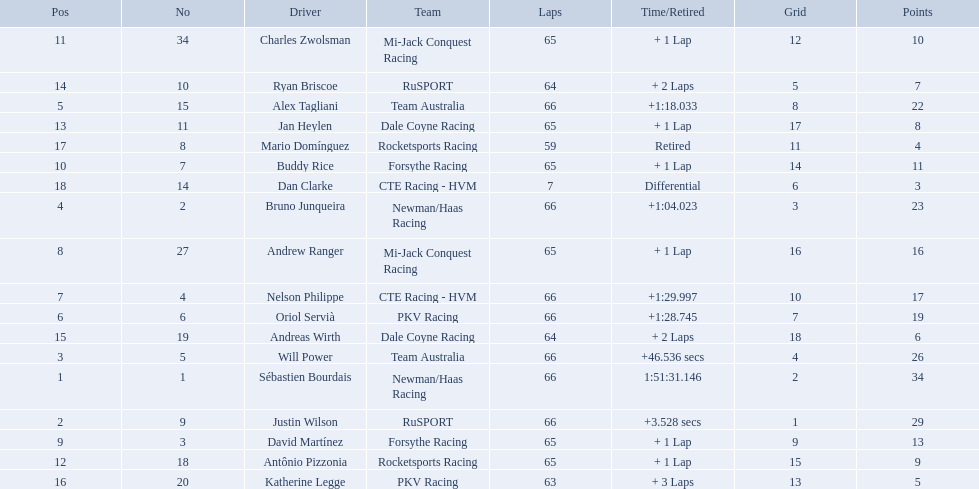Who are the drivers? Sébastien Bourdais, Justin Wilson, Will Power, Bruno Junqueira, Alex Tagliani, Oriol Servià, Nelson Philippe, Andrew Ranger, David Martínez, Buddy Rice, Charles Zwolsman, Antônio Pizzonia, Jan Heylen, Ryan Briscoe, Andreas Wirth, Katherine Legge, Mario Domínguez, Dan Clarke. What are their numbers? 1, 9, 5, 2, 15, 6, 4, 27, 3, 7, 34, 18, 11, 10, 19, 20, 8, 14. What are their positions? 1, 2, 3, 4, 5, 6, 7, 8, 9, 10, 11, 12, 13, 14, 15, 16, 17, 18. Which driver has the same number and position? Sébastien Bourdais. Which people scored 29+ points? Sébastien Bourdais, Justin Wilson. Who scored higher? Sébastien Bourdais. 